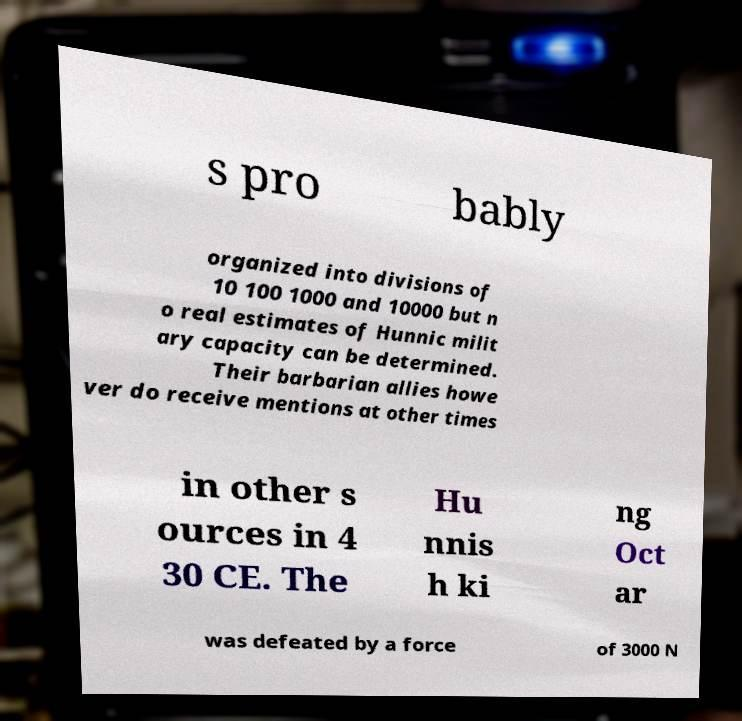I need the written content from this picture converted into text. Can you do that? s pro bably organized into divisions of 10 100 1000 and 10000 but n o real estimates of Hunnic milit ary capacity can be determined. Their barbarian allies howe ver do receive mentions at other times in other s ources in 4 30 CE. The Hu nnis h ki ng Oct ar was defeated by a force of 3000 N 